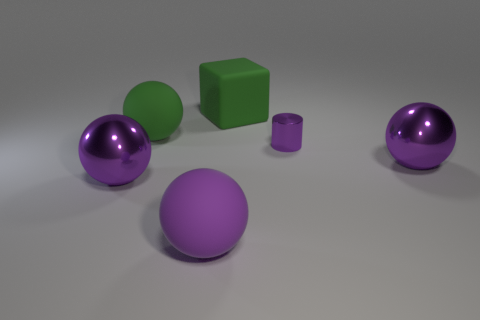What material is the purple sphere behind the metal ball that is in front of the large ball on the right side of the matte cube made of?
Make the answer very short. Metal. Is the shape of the tiny purple metallic object the same as the purple rubber thing?
Ensure brevity in your answer.  No. The large green object that is made of the same material as the green sphere is what shape?
Your answer should be very brief. Cube. How many small things are brown metal things or green rubber objects?
Provide a short and direct response. 0. There is a purple metal thing that is to the right of the tiny purple cylinder; are there any big purple rubber things on the right side of it?
Keep it short and to the point. No. Are any purple objects visible?
Ensure brevity in your answer.  Yes. There is a metal sphere that is behind the purple metallic sphere to the left of the big green ball; what color is it?
Offer a very short reply. Purple. What number of purple matte things have the same size as the green cube?
Your answer should be very brief. 1. What size is the purple object that is the same material as the big green cube?
Your response must be concise. Large. How many purple metallic objects are the same shape as the purple rubber object?
Provide a succinct answer. 2. 